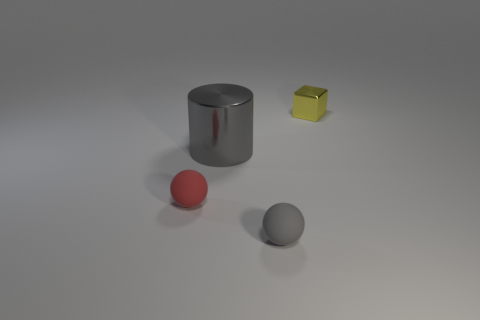What number of rubber things are either yellow blocks or small blue blocks?
Keep it short and to the point. 0. Are there fewer big brown shiny things than small balls?
Provide a succinct answer. Yes. How many other things are made of the same material as the tiny cube?
Provide a succinct answer. 1. The other rubber object that is the same shape as the red thing is what size?
Your answer should be compact. Small. Do the sphere that is left of the big metallic cylinder and the gray object behind the red matte ball have the same material?
Your answer should be very brief. No. Are there fewer rubber balls to the left of the tiny red object than matte things?
Your response must be concise. Yes. Are there any other things that have the same shape as the tiny gray rubber thing?
Provide a succinct answer. Yes. The other tiny object that is the same shape as the gray rubber thing is what color?
Your answer should be compact. Red. Is the size of the rubber sphere left of the gray metallic cylinder the same as the yellow shiny cube?
Ensure brevity in your answer.  Yes. What size is the gray object that is to the left of the matte ball that is to the right of the small red thing?
Your answer should be very brief. Large. 